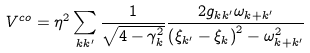Convert formula to latex. <formula><loc_0><loc_0><loc_500><loc_500>V ^ { c o } = \eta ^ { 2 } \sum _ { k k ^ { \prime } } \frac { 1 } { \sqrt { 4 - \gamma _ { k } ^ { 2 } } } \frac { 2 g _ { k k ^ { \prime } } \omega _ { k + k ^ { \prime } } } { \left ( \xi _ { k ^ { \prime } } - \xi _ { k } \right ) ^ { 2 } - \omega _ { k + k ^ { \prime } } ^ { 2 } }</formula> 